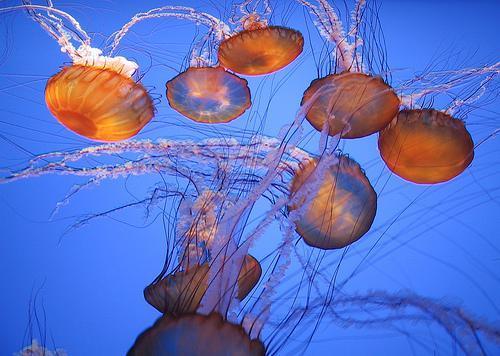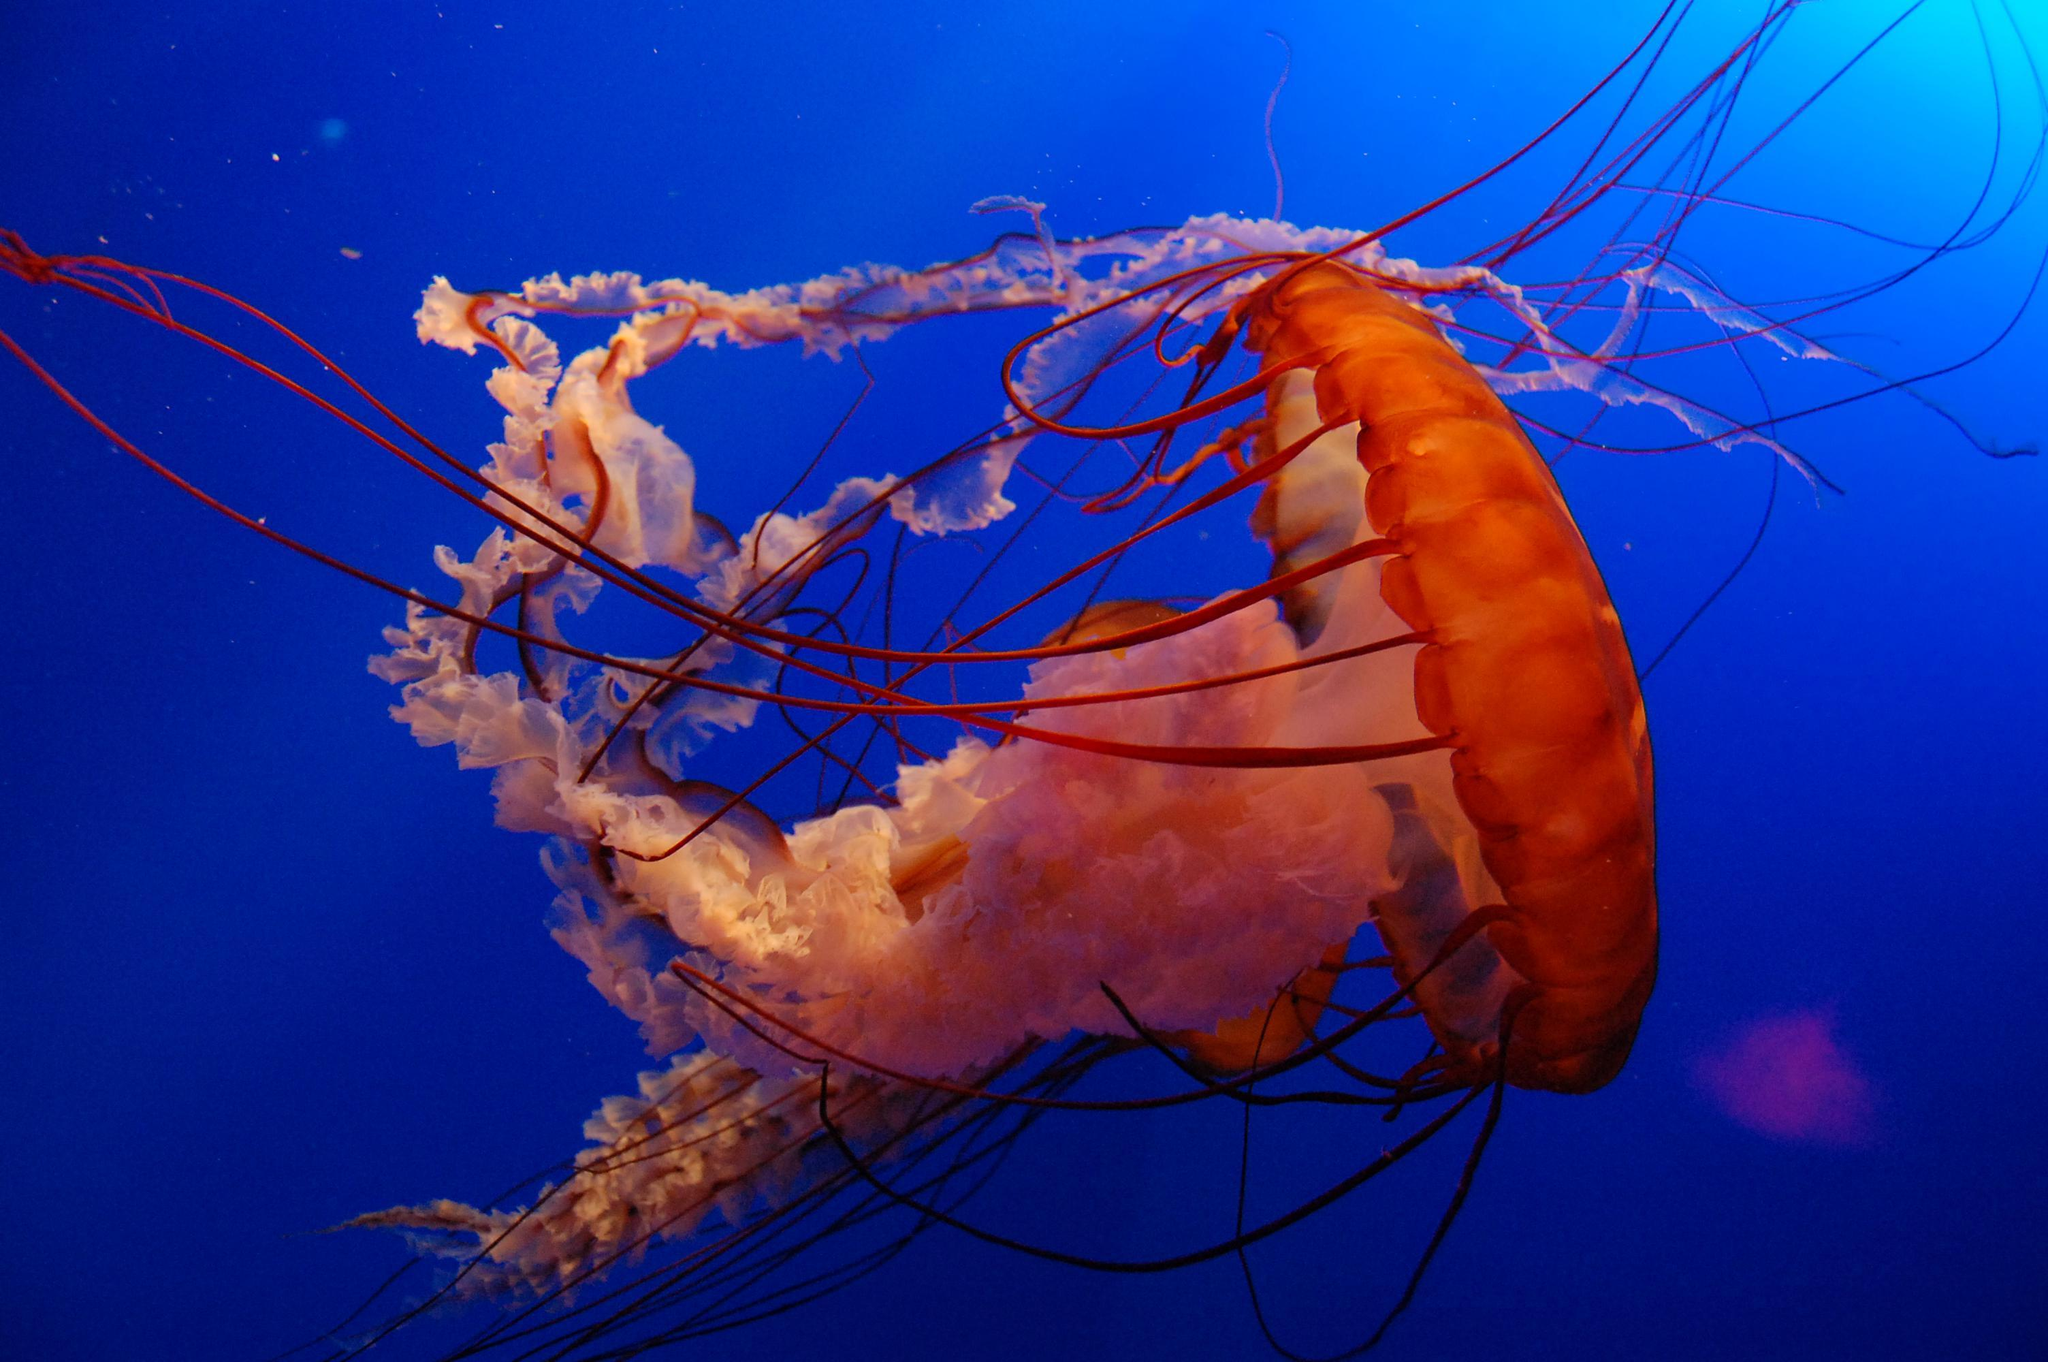The first image is the image on the left, the second image is the image on the right. Analyze the images presented: Is the assertion "An image shows at least six vivid orange jellyfish trailing tendrils." valid? Answer yes or no. Yes. 